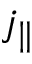Convert formula to latex. <formula><loc_0><loc_0><loc_500><loc_500>j _ { \| }</formula> 